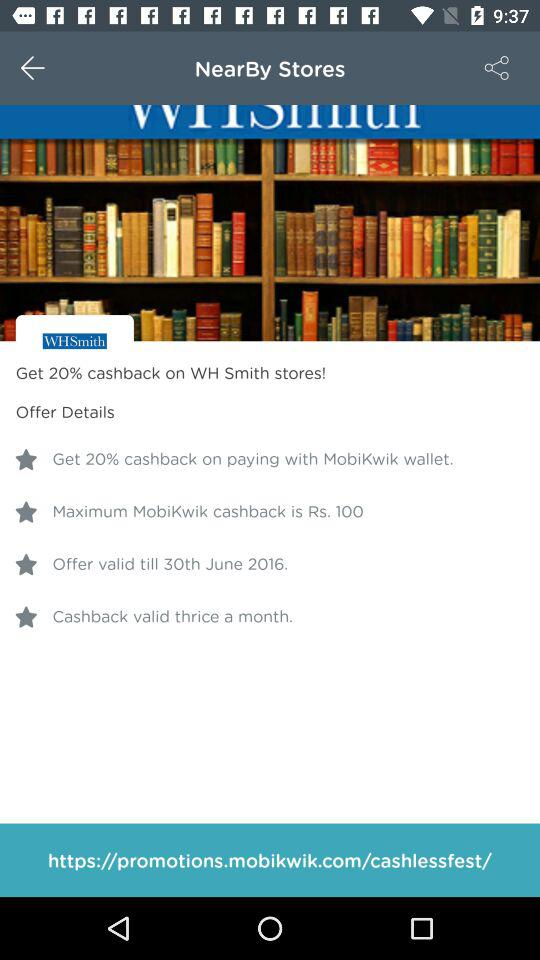How many times can cashback be valid? Cashback is valid thrice a month. 